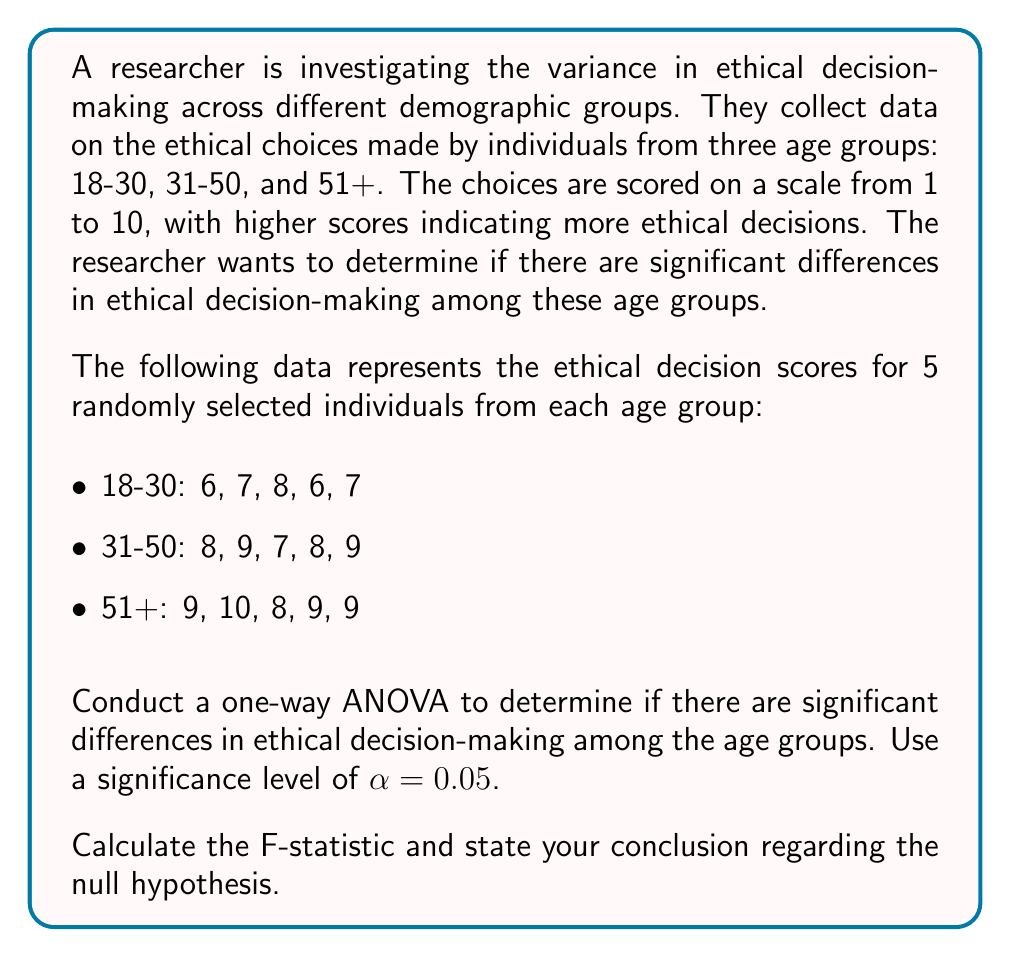Teach me how to tackle this problem. To conduct a one-way ANOVA, we need to follow these steps:

1. Calculate the sum of squares between groups (SSB)
2. Calculate the sum of squares within groups (SSW)
3. Calculate the total sum of squares (SST)
4. Calculate the degrees of freedom (df)
5. Calculate the mean squares
6. Calculate the F-statistic
7. Compare the F-statistic to the critical F-value

Step 1: Calculate SSB

First, we need to find the grand mean and group means:

Grand mean: $\bar{X} = \frac{6+7+8+6+7+8+9+7+8+9+9+10+8+9+9}{15} = 8$

Group means:
18-30: $\bar{X}_1 = \frac{6+7+8+6+7}{5} = 6.8$
31-50: $\bar{X}_2 = \frac{8+9+7+8+9}{5} = 8.2$
51+: $\bar{X}_3 = \frac{9+10+8+9+9}{5} = 9$

Now we can calculate SSB:
$$SSB = \sum_{i=1}^k n_i(\bar{X}_i - \bar{X})^2$$
$$SSB = 5(6.8-8)^2 + 5(8.2-8)^2 + 5(9-8)^2 = 5(1.44 + 0.04 + 1) = 12.4$$

Step 2: Calculate SSW

$$SSW = \sum_{i=1}^k \sum_{j=1}^{n_i} (X_{ij} - \bar{X}_i)^2$$

18-30: $(6-6.8)^2 + (7-6.8)^2 + (8-6.8)^2 + (6-6.8)^2 + (7-6.8)^2 = 2.8$
31-50: $(8-8.2)^2 + (9-8.2)^2 + (7-8.2)^2 + (8-8.2)^2 + (9-8.2)^2 = 2.8$
51+: $(9-9)^2 + (10-9)^2 + (8-9)^2 + (9-9)^2 + (9-9)^2 = 2$

$$SSW = 2.8 + 2.8 + 2 = 7.6$$

Step 3: Calculate SST

$$SST = SSB + SSW = 12.4 + 7.6 = 20$$

Step 4: Calculate degrees of freedom

df between groups (dfB) = k - 1 = 3 - 1 = 2
df within groups (dfW) = N - k = 15 - 3 = 12
df total = N - 1 = 15 - 1 = 14

Step 5: Calculate mean squares

$$MSB = \frac{SSB}{dfB} = \frac{12.4}{2} = 6.2$$
$$MSW = \frac{SSW}{dfW} = \frac{7.6}{12} = 0.633$$

Step 6: Calculate F-statistic

$$F = \frac{MSB}{MSW} = \frac{6.2}{0.633} = 9.79$$

Step 7: Compare F-statistic to critical F-value

The critical F-value for α = 0.05, dfB = 2, and dfW = 12 is approximately 3.89 (from an F-distribution table).

Since our calculated F-statistic (9.79) is greater than the critical F-value (3.89), we reject the null hypothesis.
Answer: The calculated F-statistic is 9.79. Since this value is greater than the critical F-value of 3.89, we reject the null hypothesis. We conclude that there are significant differences in ethical decision-making among the age groups at the 0.05 significance level. 